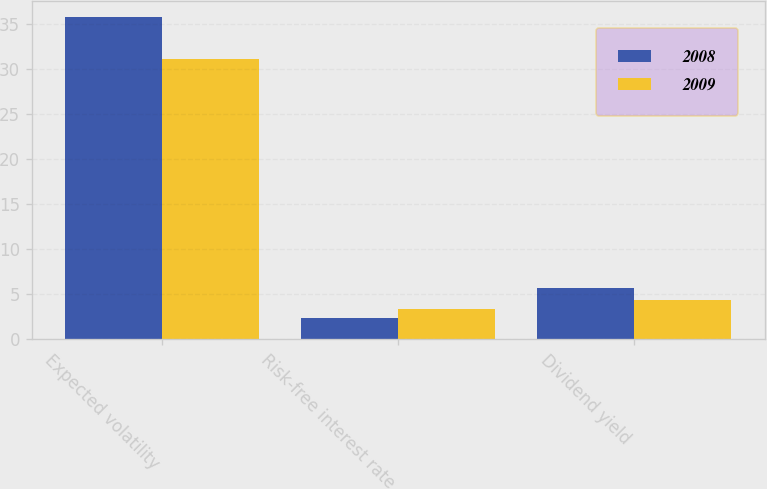Convert chart. <chart><loc_0><loc_0><loc_500><loc_500><stacked_bar_chart><ecel><fcel>Expected volatility<fcel>Risk-free interest rate<fcel>Dividend yield<nl><fcel>2008<fcel>35.8<fcel>2.4<fcel>5.7<nl><fcel>2009<fcel>31.1<fcel>3.3<fcel>4.3<nl></chart> 